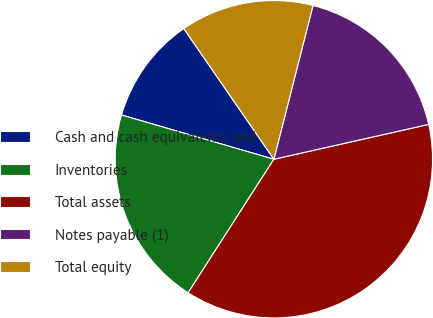Convert chart. <chart><loc_0><loc_0><loc_500><loc_500><pie_chart><fcel>Cash and cash equivalents and<fcel>Inventories<fcel>Total assets<fcel>Notes payable (1)<fcel>Total equity<nl><fcel>10.9%<fcel>20.41%<fcel>37.61%<fcel>17.51%<fcel>13.57%<nl></chart> 